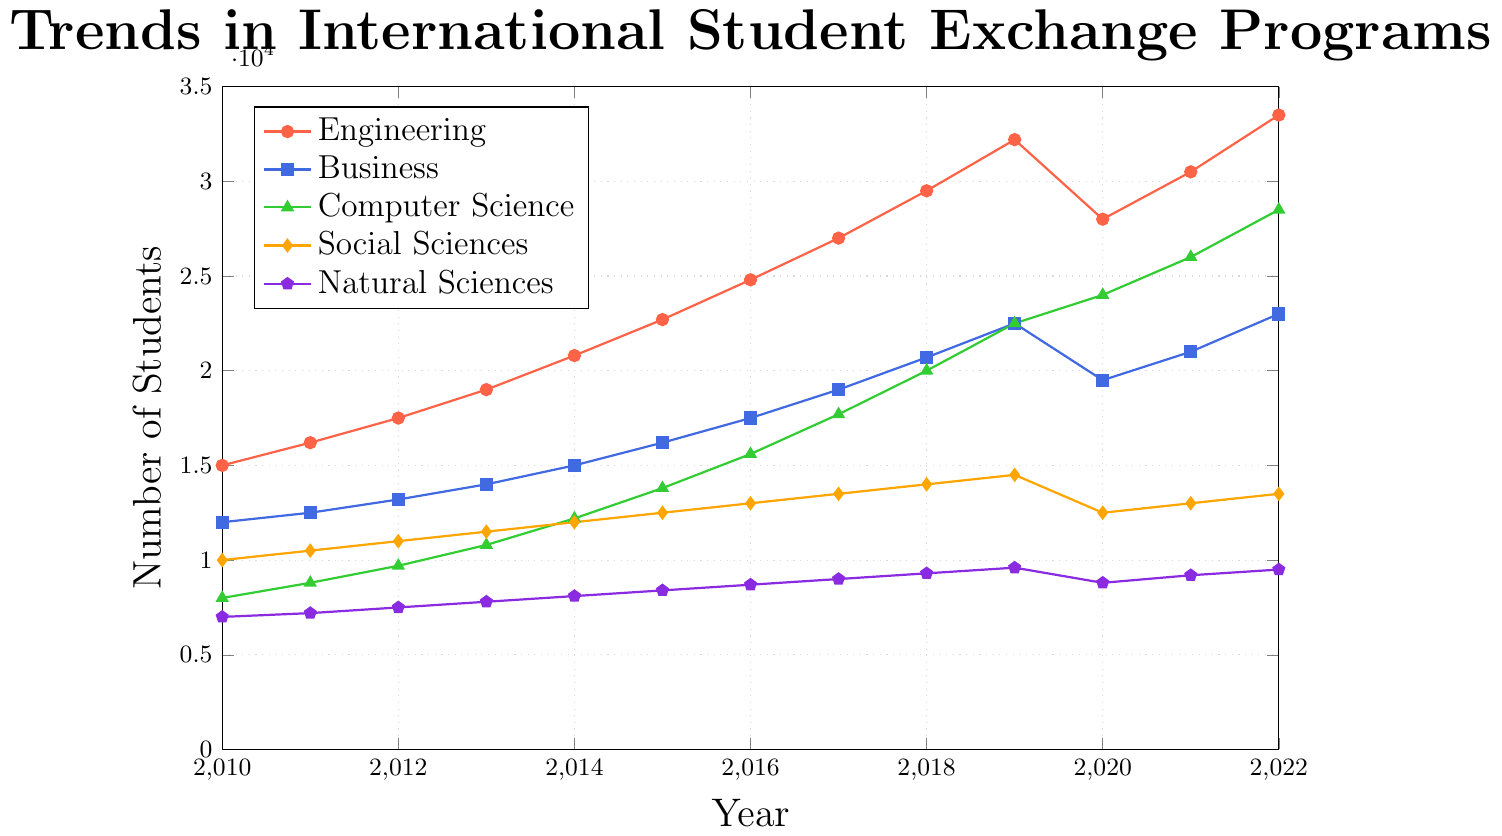What's the trend for Computer Science students from 2010 to 2022? To determine the trend for Computer Science students, observe the line marked with triangles. From 2010 (8000 students) the number increases steadily up to 28500 students in 2022.
Answer: Steadily increasing Which field had the highest number of students in 2022? Locate the end of each line at the year 2022. The line for Engineering peaks at 33500 students, higher than any other field.
Answer: Engineering By how many students did the number of Business students increase between 2010 and 2022? Find the number of Business students in 2010 (12000) and in 2022 (23000). Subtract the former from the latter: 23000 - 12000.
Answer: 11000 What was the average number of Social Sciences students from 2010 to 2022? Sum the number of Social Sciences students for each year: (10000 + 10500 + 11000 + 11500 + 12000 + 12500 + 13000 + 13500 + 14000 + 14500 + 12500 + 13000 + 13500) = 164000. Divide by the number of years (13).
Answer: 12615 Compare the trend of Natural Sciences students in 2019 to 2020 with that from 2020 to 2021. Is it increasing or decreasing in each period? Observe the line marked with pentagons. From 2019 (9600) to 2020 (8800) it decreases, and from 2020 (8800) to 2021 (9200) it increases.
Answer: Decreasing, then increasing Which field saw the largest decrease in student numbers between any two consecutive years? Identify drops in the lines. The largest drop occurs in Engineering from 2019 (32200) to 2020 (28000), a decrease of 4200 students.
Answer: Engineering (2019-2020) In which year did Computer Science see the highest year-over-year increase in student numbers? Analyze year-over-year increases. The largest increase occurs between 2021 (26000) and 2022 (28500); 28500 - 26000 = 2500 students.
Answer: 2022 How do the trends for Engineering and Business compare from 2010 to 2022? Compare the slopes of the lines marked for Engineering and Business. Both increase, but Engineering generally increases faster, especially noticeable from steeper slopes.
Answer: Both increase, Engineering faster What was the total number of exchange students across all fields in the year 2015? Sum the number of students in all fields for 2015: 22700 (Engineering) + 16200 (Business) + 13800 (Computer Science) + 12500 (Social Sciences) + 8400 (Natural Sciences) = 73600.
Answer: 73600 